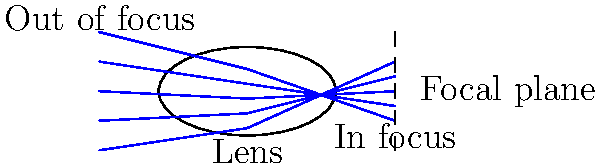As a documentary filmmaker, you're shooting a scene with varying depths. How does the refraction of light through your camera lens affect the depth of field in your shot, and how can you manipulate this to create a desired visual effect? 1. Refraction in camera lenses:
   - Light bends (refracts) when passing through the lens due to the change in medium.
   - The amount of refraction depends on the lens shape and refractive index.

2. Depth of field (DOF):
   - DOF is the range of distances where objects appear acceptably sharp in an image.
   - It's determined by the lens aperture, focal length, and distance to the subject.

3. Relationship between refraction and DOF:
   - The lens focuses light rays from the subject onto the camera sensor.
   - Objects at the focal plane appear sharp, while those in front or behind are blurred.
   - The degree of refraction affects where light rays converge, influencing the DOF.

4. Aperture and DOF:
   - A wider aperture (smaller f-number) creates a shallower DOF.
   - This is because it allows more light rays to enter at different angles, increasing refraction.
   - Formula: DOF ∝ $\frac{1}{f^2}$, where $f$ is the f-number.

5. Focal length and DOF:
   - Longer focal lengths create a shallower DOF.
   - This is due to the increased magnification and narrower angle of view.
   - Formula: DOF ∝ $\frac{1}{F^2}$, where $F$ is the focal length.

6. Manipulating DOF for visual effect:
   - Shallow DOF (wide aperture, long focal length):
     * Isolates subject from background
     * Creates a dreamy, cinematic look
   - Deep DOF (narrow aperture, short focal length):
     * Keeps more of the scene in focus
     * Useful for landscape or documentary shots requiring context

7. Practical application:
   - For interviews: Use a wider aperture to blur the background and focus on the subject.
   - For environmental shots: Use a narrower aperture to show more of the surroundings in focus.
Answer: Refraction through the lens determines where light rays converge, affecting DOF. Wider apertures and longer focal lengths create shallower DOF, while narrower apertures and shorter focal lengths increase DOF. Filmmakers can manipulate these factors to isolate subjects or show more context in their shots. 